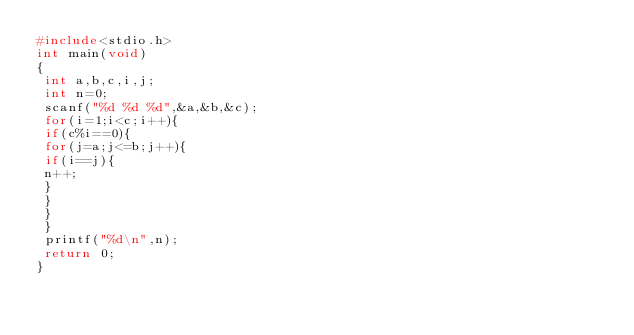<code> <loc_0><loc_0><loc_500><loc_500><_C_>#include<stdio.h>
int main(void)
{
 int a,b,c,i,j;
 int n=0;
 scanf("%d %d %d",&a,&b,&c);
 for(i=1;i<c;i++){
 if(c%i==0){
 for(j=a;j<=b;j++){
 if(i==j){
 n++;
 }
 }
 }
 }
 printf("%d\n",n);
 return 0;
}</code> 